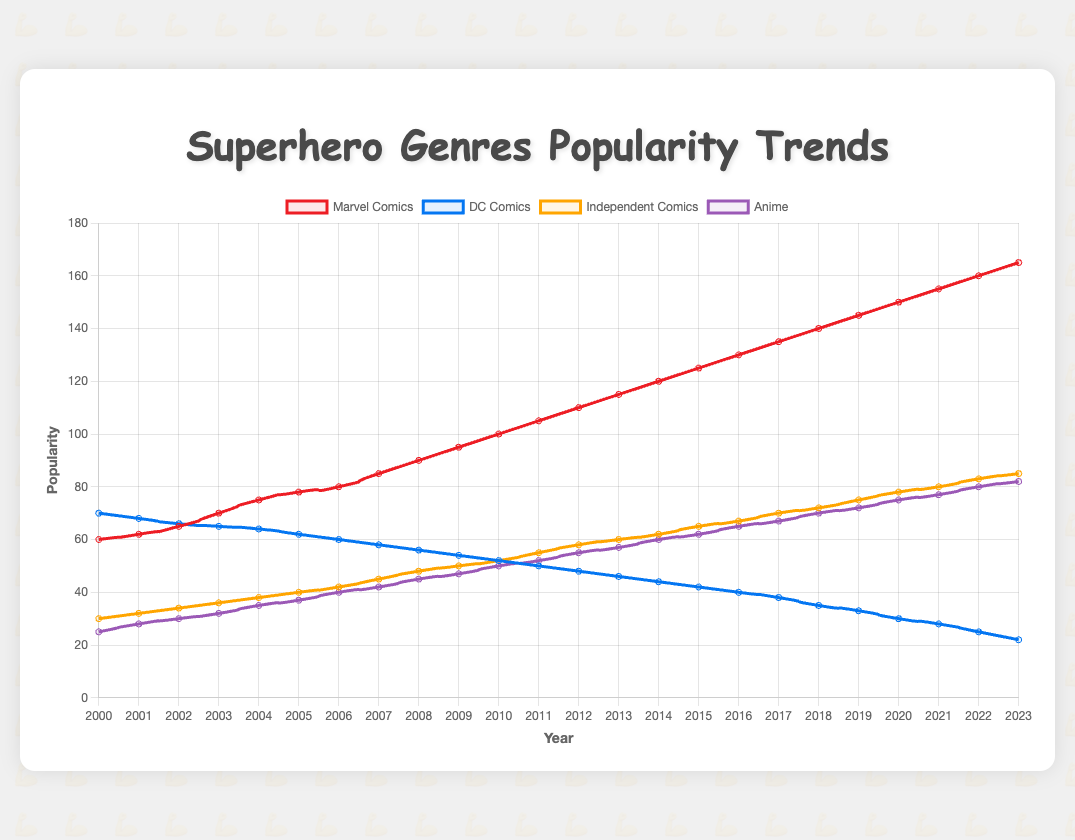Which genre had the highest popularity in the year 2000? In the year 2000, we can see that the highest point on the y-axis, representing popularity, belongs to DC Comics with a value of 70.
Answer: DC Comics How many years did Marvel Comics lead in popularity above all other genres? By examining the plot, Marvel Comics surpasses all other genres starting from the year 2002 and continues to lead until 2023. The difference is 2023 - 2002 + 1 = 22 years.
Answer: 22 years Between which two years did Anime see the highest increase in popularity? By observing the y-axis values of Anime, the largest jump is between 2007 (42) and 2008 (45). The increase is 45 - 42 = 3.
Answer: Between 2007 and 2008 In what year did Independent Comics' popularity surpass that of DC Comics? Looking at the plot, we see Independent Comics surpass DC Comics in 2010 where both meet, with Independent Comics continuing to increase.
Answer: 2010 What was the popularity of DC Comics in the year 2016, and how much did it decrease from the previous year? In 2016, the popularity of DC Comics was 40. From the previous year, it decreased from 42 to 40. The decrease is 42 - 40 = 2.
Answer: 2 Compare the popularity of Marvel Comics and Anime in the year 2023. Which one is higher and by how much? In 2023, Marvel Comics is at 165, and Anime is at 82. The difference is 165 - 82 = 83. Marvel Comics is higher by 83.
Answer: Marvel Comics by 83 What's the average popularity of Anime from 2000 to 2023? The popularity values of Anime from 2000 to 2023 are summed up (25 + 28 + 30 + 32 + 35 + 37 + 40 + 42 + 45 + 47 + 50 + 52 + 55 + 57 + 60 + 62 + 65 + 67 + 70 + 72 + 75 + 77 + 80 + 82 = 1367) and then divided by the number of years (24). The average is 1367 / 24 ≈ 56.96.
Answer: 56.96 What is the trend of DC Comics' popularity from 2010 to 2023? DC Comics shows a decreasing trend from 2010 to 2023, going from a value of 52 in 2010 down to 22 in 2023.
Answer: Decreasing In what year did Marvel Comics’ popularity first hit 100 points? Marvel Comics first hit 100 points in the year 2010.
Answer: 2010 Which genre saw the least increase in popularity from 2000 to 2023? By comparing the four genres, DC Comics increased from 70 to 22, which actually shows a decrease. Thus, DC Comics saw the least increase (even decrease).
Answer: DC Comics 